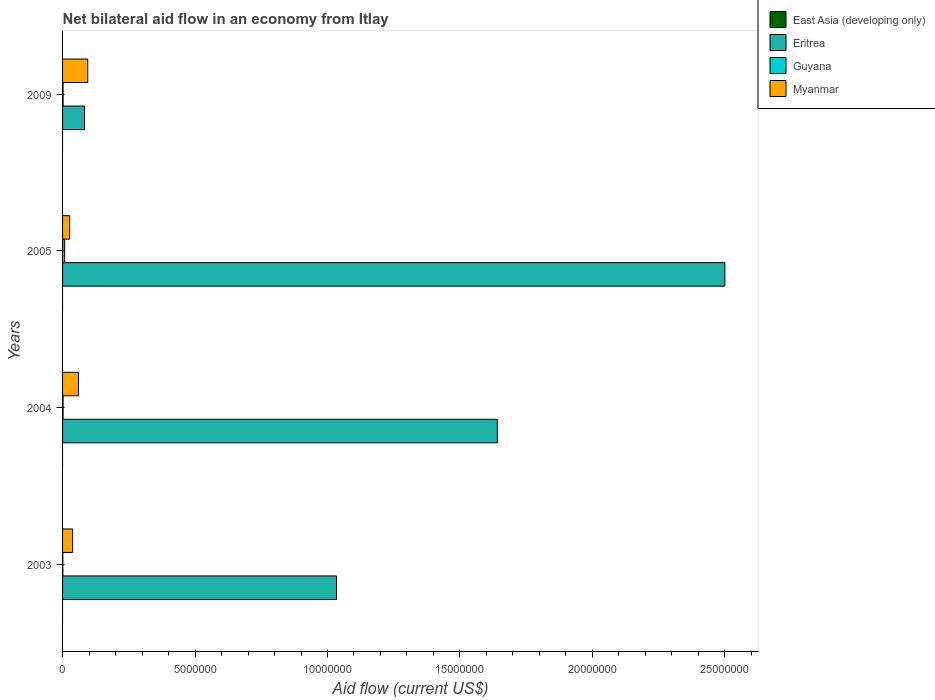Are the number of bars per tick equal to the number of legend labels?
Make the answer very short. No. How many bars are there on the 3rd tick from the top?
Your response must be concise. 3. What is the label of the 3rd group of bars from the top?
Provide a short and direct response. 2004. What is the net bilateral aid flow in Myanmar in 2009?
Your answer should be compact. 9.50e+05. Across all years, what is the minimum net bilateral aid flow in Guyana?
Provide a succinct answer. 10000. In which year was the net bilateral aid flow in Eritrea maximum?
Provide a short and direct response. 2005. What is the difference between the net bilateral aid flow in Guyana in 2004 and the net bilateral aid flow in East Asia (developing only) in 2009?
Provide a short and direct response. 2.00e+04. What is the average net bilateral aid flow in Guyana per year?
Offer a terse response. 3.25e+04. In the year 2005, what is the difference between the net bilateral aid flow in Myanmar and net bilateral aid flow in Eritrea?
Give a very brief answer. -2.47e+07. In how many years, is the net bilateral aid flow in Eritrea greater than 5000000 US$?
Offer a terse response. 3. What is the ratio of the net bilateral aid flow in Eritrea in 2003 to that in 2009?
Your response must be concise. 12.46. What is the difference between the highest and the second highest net bilateral aid flow in Eritrea?
Make the answer very short. 8.59e+06. What is the difference between the highest and the lowest net bilateral aid flow in Eritrea?
Ensure brevity in your answer.  2.42e+07. In how many years, is the net bilateral aid flow in Myanmar greater than the average net bilateral aid flow in Myanmar taken over all years?
Make the answer very short. 2. Is the sum of the net bilateral aid flow in Myanmar in 2003 and 2009 greater than the maximum net bilateral aid flow in East Asia (developing only) across all years?
Your answer should be compact. Yes. How many bars are there?
Offer a very short reply. 12. What is the difference between two consecutive major ticks on the X-axis?
Your answer should be compact. 5.00e+06. Does the graph contain any zero values?
Your response must be concise. Yes. Does the graph contain grids?
Provide a succinct answer. No. Where does the legend appear in the graph?
Your response must be concise. Top right. What is the title of the graph?
Your answer should be compact. Net bilateral aid flow in an economy from Itlay. Does "Malaysia" appear as one of the legend labels in the graph?
Your answer should be very brief. No. What is the label or title of the X-axis?
Make the answer very short. Aid flow (current US$). What is the Aid flow (current US$) of Eritrea in 2003?
Your response must be concise. 1.03e+07. What is the Aid flow (current US$) of East Asia (developing only) in 2004?
Your answer should be very brief. 0. What is the Aid flow (current US$) in Eritrea in 2004?
Give a very brief answer. 1.64e+07. What is the Aid flow (current US$) of Eritrea in 2005?
Ensure brevity in your answer.  2.50e+07. What is the Aid flow (current US$) of Guyana in 2005?
Keep it short and to the point. 8.00e+04. What is the Aid flow (current US$) in Myanmar in 2005?
Offer a very short reply. 2.70e+05. What is the Aid flow (current US$) of Eritrea in 2009?
Ensure brevity in your answer.  8.30e+05. What is the Aid flow (current US$) of Guyana in 2009?
Give a very brief answer. 2.00e+04. What is the Aid flow (current US$) in Myanmar in 2009?
Ensure brevity in your answer.  9.50e+05. Across all years, what is the maximum Aid flow (current US$) in Eritrea?
Offer a terse response. 2.50e+07. Across all years, what is the maximum Aid flow (current US$) in Myanmar?
Offer a terse response. 9.50e+05. Across all years, what is the minimum Aid flow (current US$) of Eritrea?
Provide a succinct answer. 8.30e+05. Across all years, what is the minimum Aid flow (current US$) in Myanmar?
Keep it short and to the point. 2.70e+05. What is the total Aid flow (current US$) of East Asia (developing only) in the graph?
Provide a succinct answer. 0. What is the total Aid flow (current US$) of Eritrea in the graph?
Your answer should be very brief. 5.26e+07. What is the total Aid flow (current US$) in Guyana in the graph?
Give a very brief answer. 1.30e+05. What is the total Aid flow (current US$) of Myanmar in the graph?
Provide a succinct answer. 2.20e+06. What is the difference between the Aid flow (current US$) in Eritrea in 2003 and that in 2004?
Your answer should be very brief. -6.07e+06. What is the difference between the Aid flow (current US$) of Guyana in 2003 and that in 2004?
Your answer should be compact. -10000. What is the difference between the Aid flow (current US$) of Myanmar in 2003 and that in 2004?
Your response must be concise. -2.20e+05. What is the difference between the Aid flow (current US$) in Eritrea in 2003 and that in 2005?
Offer a terse response. -1.47e+07. What is the difference between the Aid flow (current US$) of Myanmar in 2003 and that in 2005?
Your answer should be very brief. 1.10e+05. What is the difference between the Aid flow (current US$) in Eritrea in 2003 and that in 2009?
Offer a terse response. 9.51e+06. What is the difference between the Aid flow (current US$) of Myanmar in 2003 and that in 2009?
Offer a very short reply. -5.70e+05. What is the difference between the Aid flow (current US$) in Eritrea in 2004 and that in 2005?
Give a very brief answer. -8.59e+06. What is the difference between the Aid flow (current US$) of Myanmar in 2004 and that in 2005?
Ensure brevity in your answer.  3.30e+05. What is the difference between the Aid flow (current US$) of Eritrea in 2004 and that in 2009?
Give a very brief answer. 1.56e+07. What is the difference between the Aid flow (current US$) in Myanmar in 2004 and that in 2009?
Provide a short and direct response. -3.50e+05. What is the difference between the Aid flow (current US$) of Eritrea in 2005 and that in 2009?
Keep it short and to the point. 2.42e+07. What is the difference between the Aid flow (current US$) of Guyana in 2005 and that in 2009?
Ensure brevity in your answer.  6.00e+04. What is the difference between the Aid flow (current US$) of Myanmar in 2005 and that in 2009?
Your answer should be compact. -6.80e+05. What is the difference between the Aid flow (current US$) of Eritrea in 2003 and the Aid flow (current US$) of Guyana in 2004?
Provide a short and direct response. 1.03e+07. What is the difference between the Aid flow (current US$) in Eritrea in 2003 and the Aid flow (current US$) in Myanmar in 2004?
Offer a terse response. 9.74e+06. What is the difference between the Aid flow (current US$) of Guyana in 2003 and the Aid flow (current US$) of Myanmar in 2004?
Your answer should be very brief. -5.90e+05. What is the difference between the Aid flow (current US$) of Eritrea in 2003 and the Aid flow (current US$) of Guyana in 2005?
Your answer should be compact. 1.03e+07. What is the difference between the Aid flow (current US$) in Eritrea in 2003 and the Aid flow (current US$) in Myanmar in 2005?
Your answer should be very brief. 1.01e+07. What is the difference between the Aid flow (current US$) of Eritrea in 2003 and the Aid flow (current US$) of Guyana in 2009?
Your response must be concise. 1.03e+07. What is the difference between the Aid flow (current US$) of Eritrea in 2003 and the Aid flow (current US$) of Myanmar in 2009?
Make the answer very short. 9.39e+06. What is the difference between the Aid flow (current US$) in Guyana in 2003 and the Aid flow (current US$) in Myanmar in 2009?
Provide a succinct answer. -9.40e+05. What is the difference between the Aid flow (current US$) of Eritrea in 2004 and the Aid flow (current US$) of Guyana in 2005?
Make the answer very short. 1.63e+07. What is the difference between the Aid flow (current US$) in Eritrea in 2004 and the Aid flow (current US$) in Myanmar in 2005?
Provide a short and direct response. 1.61e+07. What is the difference between the Aid flow (current US$) of Guyana in 2004 and the Aid flow (current US$) of Myanmar in 2005?
Provide a short and direct response. -2.50e+05. What is the difference between the Aid flow (current US$) of Eritrea in 2004 and the Aid flow (current US$) of Guyana in 2009?
Your answer should be compact. 1.64e+07. What is the difference between the Aid flow (current US$) in Eritrea in 2004 and the Aid flow (current US$) in Myanmar in 2009?
Keep it short and to the point. 1.55e+07. What is the difference between the Aid flow (current US$) in Guyana in 2004 and the Aid flow (current US$) in Myanmar in 2009?
Keep it short and to the point. -9.30e+05. What is the difference between the Aid flow (current US$) of Eritrea in 2005 and the Aid flow (current US$) of Guyana in 2009?
Your answer should be very brief. 2.50e+07. What is the difference between the Aid flow (current US$) of Eritrea in 2005 and the Aid flow (current US$) of Myanmar in 2009?
Your answer should be very brief. 2.40e+07. What is the difference between the Aid flow (current US$) of Guyana in 2005 and the Aid flow (current US$) of Myanmar in 2009?
Your response must be concise. -8.70e+05. What is the average Aid flow (current US$) in East Asia (developing only) per year?
Your answer should be very brief. 0. What is the average Aid flow (current US$) of Eritrea per year?
Give a very brief answer. 1.31e+07. What is the average Aid flow (current US$) in Guyana per year?
Make the answer very short. 3.25e+04. What is the average Aid flow (current US$) of Myanmar per year?
Your answer should be very brief. 5.50e+05. In the year 2003, what is the difference between the Aid flow (current US$) in Eritrea and Aid flow (current US$) in Guyana?
Your answer should be compact. 1.03e+07. In the year 2003, what is the difference between the Aid flow (current US$) in Eritrea and Aid flow (current US$) in Myanmar?
Give a very brief answer. 9.96e+06. In the year 2003, what is the difference between the Aid flow (current US$) of Guyana and Aid flow (current US$) of Myanmar?
Give a very brief answer. -3.70e+05. In the year 2004, what is the difference between the Aid flow (current US$) in Eritrea and Aid flow (current US$) in Guyana?
Make the answer very short. 1.64e+07. In the year 2004, what is the difference between the Aid flow (current US$) in Eritrea and Aid flow (current US$) in Myanmar?
Your answer should be compact. 1.58e+07. In the year 2004, what is the difference between the Aid flow (current US$) in Guyana and Aid flow (current US$) in Myanmar?
Ensure brevity in your answer.  -5.80e+05. In the year 2005, what is the difference between the Aid flow (current US$) of Eritrea and Aid flow (current US$) of Guyana?
Ensure brevity in your answer.  2.49e+07. In the year 2005, what is the difference between the Aid flow (current US$) in Eritrea and Aid flow (current US$) in Myanmar?
Provide a short and direct response. 2.47e+07. In the year 2005, what is the difference between the Aid flow (current US$) of Guyana and Aid flow (current US$) of Myanmar?
Make the answer very short. -1.90e+05. In the year 2009, what is the difference between the Aid flow (current US$) in Eritrea and Aid flow (current US$) in Guyana?
Offer a terse response. 8.10e+05. In the year 2009, what is the difference between the Aid flow (current US$) of Eritrea and Aid flow (current US$) of Myanmar?
Your answer should be very brief. -1.20e+05. In the year 2009, what is the difference between the Aid flow (current US$) of Guyana and Aid flow (current US$) of Myanmar?
Your answer should be compact. -9.30e+05. What is the ratio of the Aid flow (current US$) in Eritrea in 2003 to that in 2004?
Ensure brevity in your answer.  0.63. What is the ratio of the Aid flow (current US$) in Myanmar in 2003 to that in 2004?
Give a very brief answer. 0.63. What is the ratio of the Aid flow (current US$) in Eritrea in 2003 to that in 2005?
Provide a succinct answer. 0.41. What is the ratio of the Aid flow (current US$) of Guyana in 2003 to that in 2005?
Your answer should be very brief. 0.12. What is the ratio of the Aid flow (current US$) in Myanmar in 2003 to that in 2005?
Make the answer very short. 1.41. What is the ratio of the Aid flow (current US$) of Eritrea in 2003 to that in 2009?
Give a very brief answer. 12.46. What is the ratio of the Aid flow (current US$) in Eritrea in 2004 to that in 2005?
Give a very brief answer. 0.66. What is the ratio of the Aid flow (current US$) of Myanmar in 2004 to that in 2005?
Your answer should be compact. 2.22. What is the ratio of the Aid flow (current US$) in Eritrea in 2004 to that in 2009?
Your answer should be very brief. 19.77. What is the ratio of the Aid flow (current US$) in Myanmar in 2004 to that in 2009?
Your response must be concise. 0.63. What is the ratio of the Aid flow (current US$) in Eritrea in 2005 to that in 2009?
Keep it short and to the point. 30.12. What is the ratio of the Aid flow (current US$) of Myanmar in 2005 to that in 2009?
Make the answer very short. 0.28. What is the difference between the highest and the second highest Aid flow (current US$) in Eritrea?
Make the answer very short. 8.59e+06. What is the difference between the highest and the second highest Aid flow (current US$) in Guyana?
Offer a very short reply. 6.00e+04. What is the difference between the highest and the lowest Aid flow (current US$) of Eritrea?
Your answer should be very brief. 2.42e+07. What is the difference between the highest and the lowest Aid flow (current US$) of Guyana?
Your response must be concise. 7.00e+04. What is the difference between the highest and the lowest Aid flow (current US$) in Myanmar?
Provide a succinct answer. 6.80e+05. 